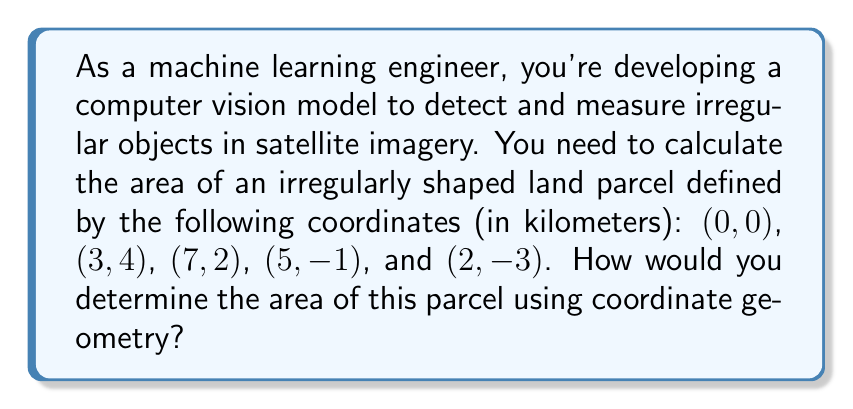Can you answer this question? To calculate the area of an irregular shape defined by coordinates, we can use the Shoelace formula (also known as the surveyor's formula). The steps are as follows:

1. List the coordinates in order (clockwise or counterclockwise):
   $(x_1, y_1) = (0, 0)$
   $(x_2, y_2) = (3, 4)$
   $(x_3, y_3) = (7, 2)$
   $(x_4, y_4) = (5, -1)$
   $(x_5, y_5) = (2, -3)$

2. Apply the Shoelace formula:
   $$A = \frac{1}{2}|(x_1y_2 + x_2y_3 + x_3y_4 + x_4y_5 + x_5y_1) - (y_1x_2 + y_2x_3 + y_3x_4 + y_4x_5 + y_5x_1)|$$

3. Substitute the values:
   $$A = \frac{1}{2}|(0 \cdot 4 + 3 \cdot 2 + 7 \cdot (-1) + 5 \cdot (-3) + 2 \cdot 0) - (0 \cdot 3 + 4 \cdot 7 + 2 \cdot 5 + (-1) \cdot 2 + (-3) \cdot 0)|$$

4. Simplify:
   $$A = \frac{1}{2}|(0 + 6 - 7 - 15 + 0) - (0 + 28 + 10 - 2 + 0)|$$
   $$A = \frac{1}{2}|(-16) - (36)|$$
   $$A = \frac{1}{2}|-52|$$
   $$A = \frac{1}{2}(52)$$
   $$A = 26$$

5. The result is in square kilometers, as the original coordinates were in kilometers.

[asy]
import geometry;

unitsize(20);
fill((0,0)--(3,4)--(7,2)--(5,-1)--(2,-3)--cycle, paleblue);
draw((0,0)--(3,4)--(7,2)--(5,-1)--(2,-3)--cycle);

dot((0,0)); dot((3,4)); dot((7,2)); dot((5,-1)); dot((2,-3));

label("(0,0)", (0,0), SW);
label("(3,4)", (3,4), NE);
label("(7,2)", (7,2), E);
label("(5,-1)", (5,-1), SE);
label("(2,-3)", (2,-3), S);

xaxis(-1,8,arrow=Arrow);
yaxis(-4,5,arrow=Arrow);
[/asy]
Answer: 26 km² 